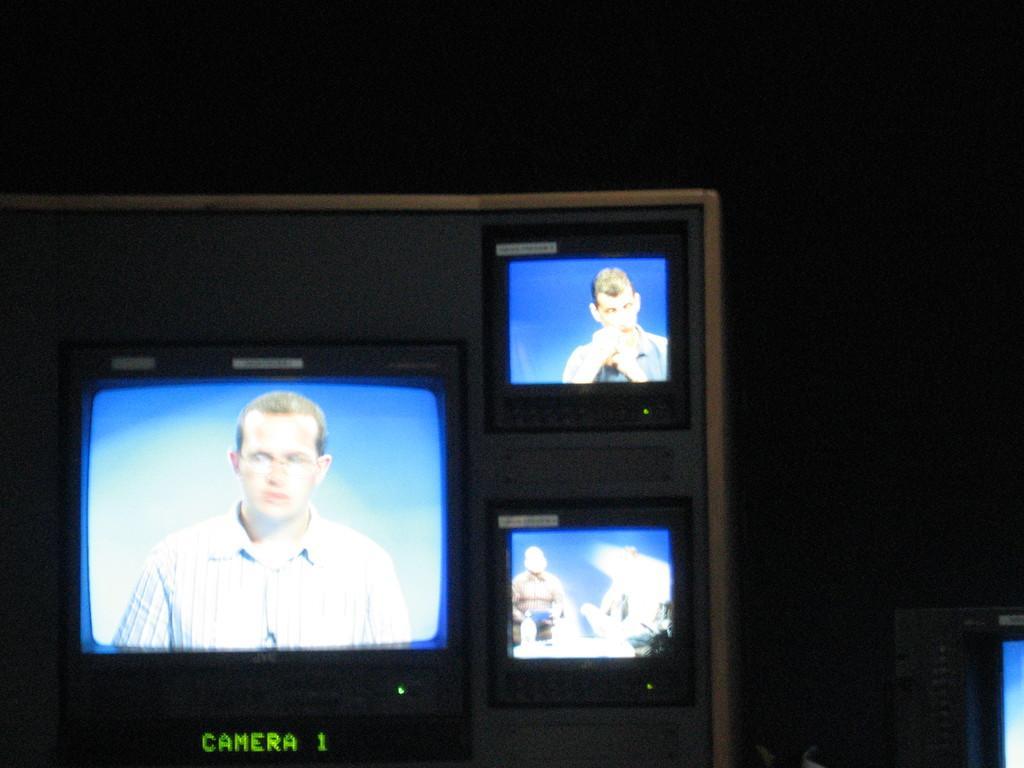How would you summarize this image in a sentence or two? In this image, I can see a set of televisions in a box. At the bottom of the image, I can see words and a number. At the bottom right side of the image, there is an object. The background is dark. 